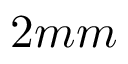Convert formula to latex. <formula><loc_0><loc_0><loc_500><loc_500>2 m m</formula> 